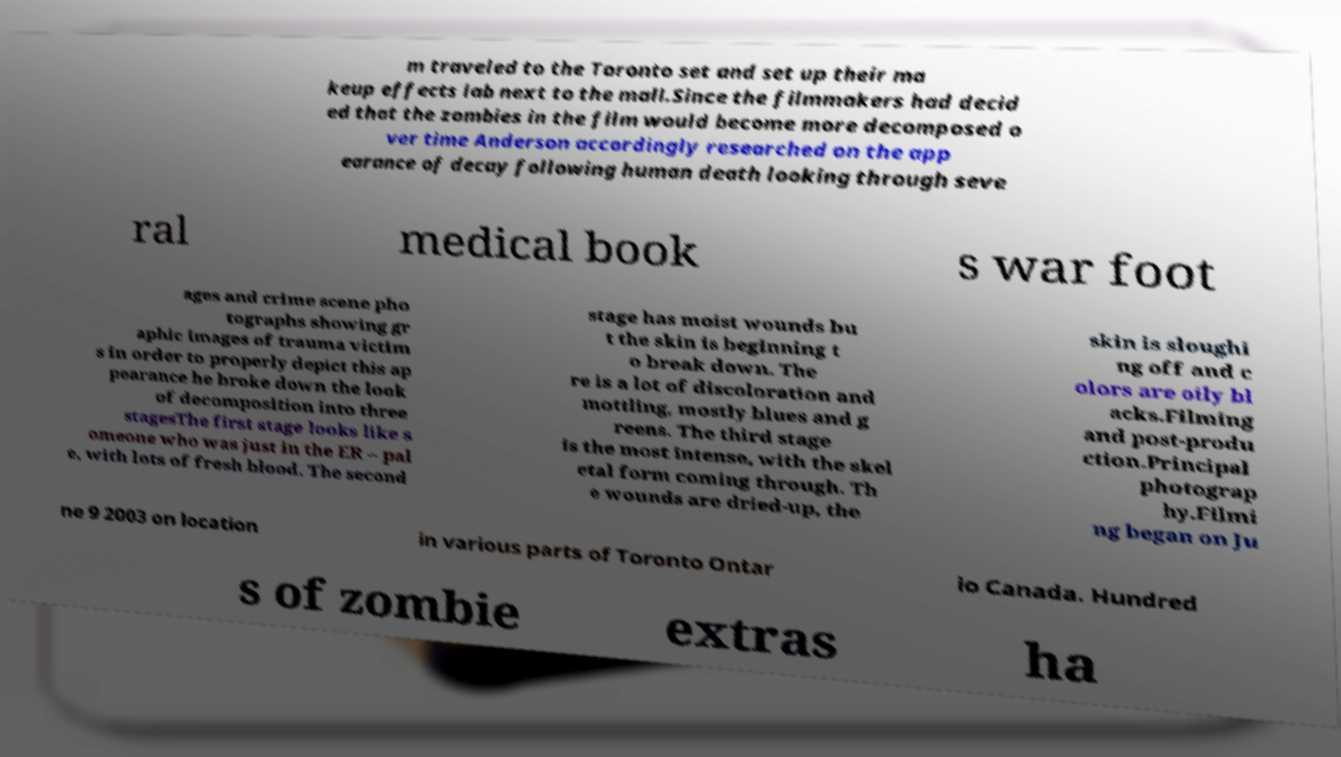Could you assist in decoding the text presented in this image and type it out clearly? m traveled to the Toronto set and set up their ma keup effects lab next to the mall.Since the filmmakers had decid ed that the zombies in the film would become more decomposed o ver time Anderson accordingly researched on the app earance of decay following human death looking through seve ral medical book s war foot ages and crime scene pho tographs showing gr aphic images of trauma victim s in order to properly depict this ap pearance he broke down the look of decomposition into three stagesThe first stage looks like s omeone who was just in the ER – pal e, with lots of fresh blood. The second stage has moist wounds bu t the skin is beginning t o break down. The re is a lot of discoloration and mottling, mostly blues and g reens. The third stage is the most intense, with the skel etal form coming through. Th e wounds are dried-up, the skin is sloughi ng off and c olors are oily bl acks.Filming and post-produ ction.Principal photograp hy.Filmi ng began on Ju ne 9 2003 on location in various parts of Toronto Ontar io Canada. Hundred s of zombie extras ha 